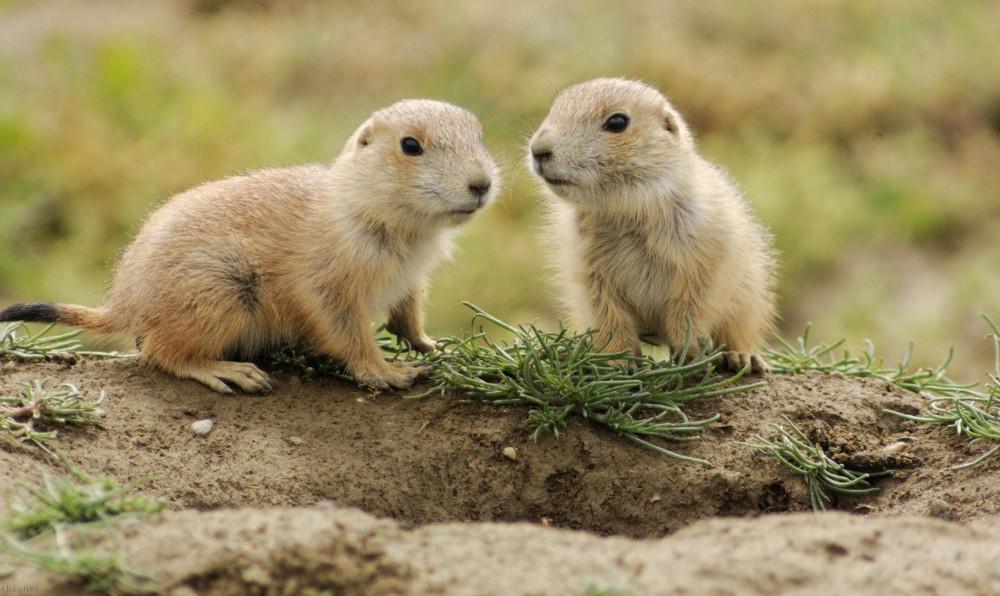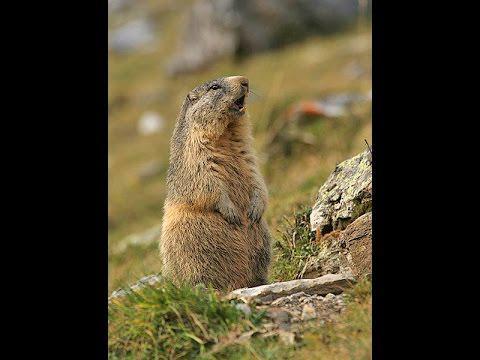The first image is the image on the left, the second image is the image on the right. Evaluate the accuracy of this statement regarding the images: "An image shows three upright marmots facing the same general direction and clutching food.". Is it true? Answer yes or no. No. 